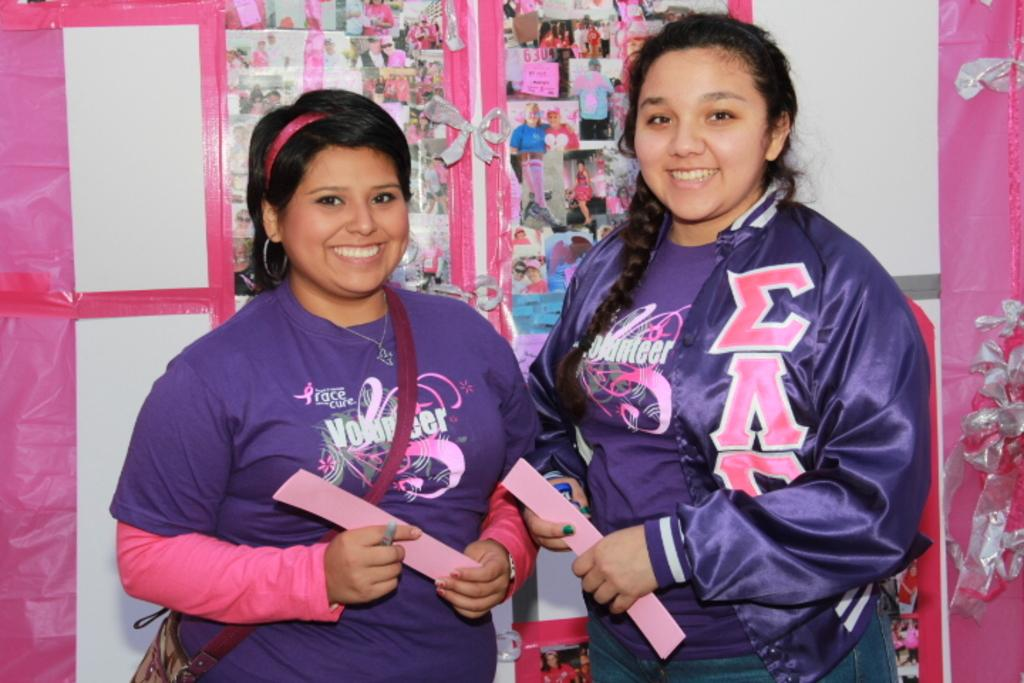Provide a one-sentence caption for the provided image. Two teen girls stand together wearing purple and pink shirts stating that they volunteered with Race for a Cure. 